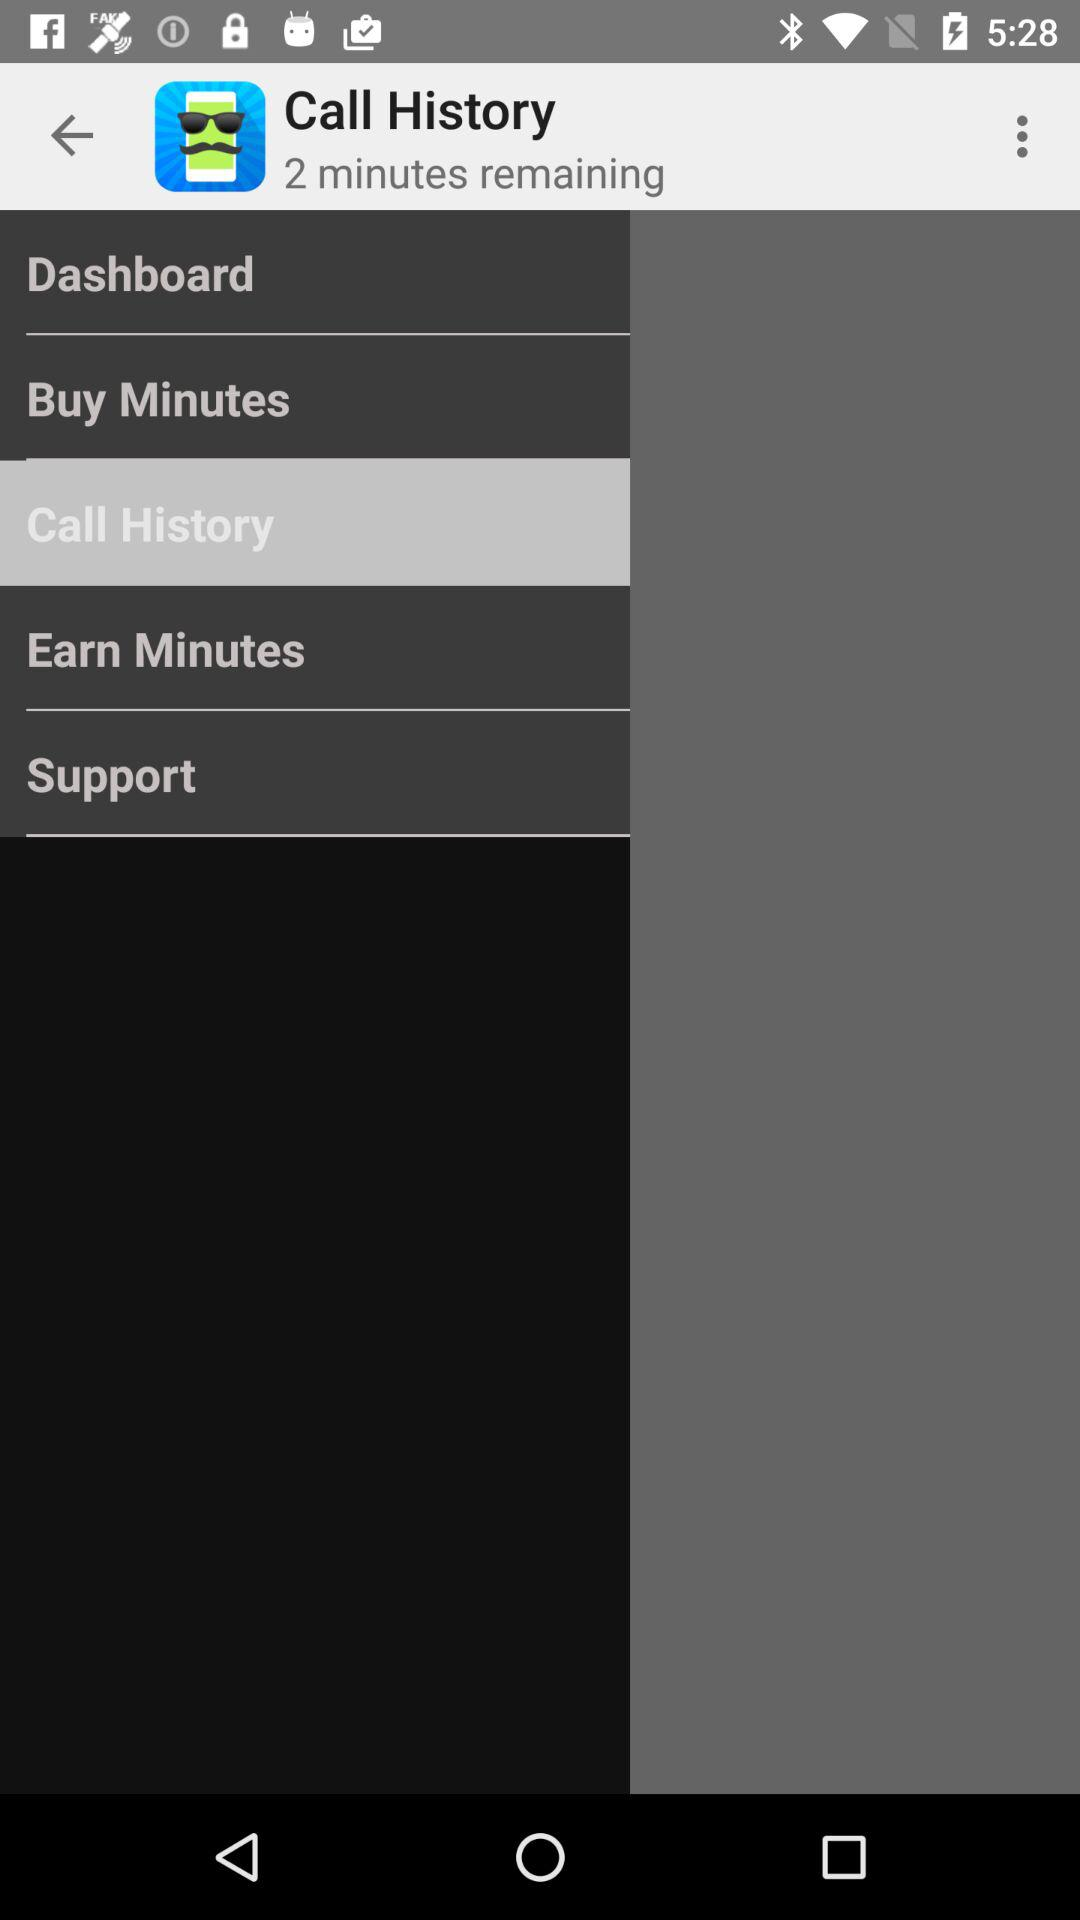How many minutes remaining do I have?
Answer the question using a single word or phrase. 2 